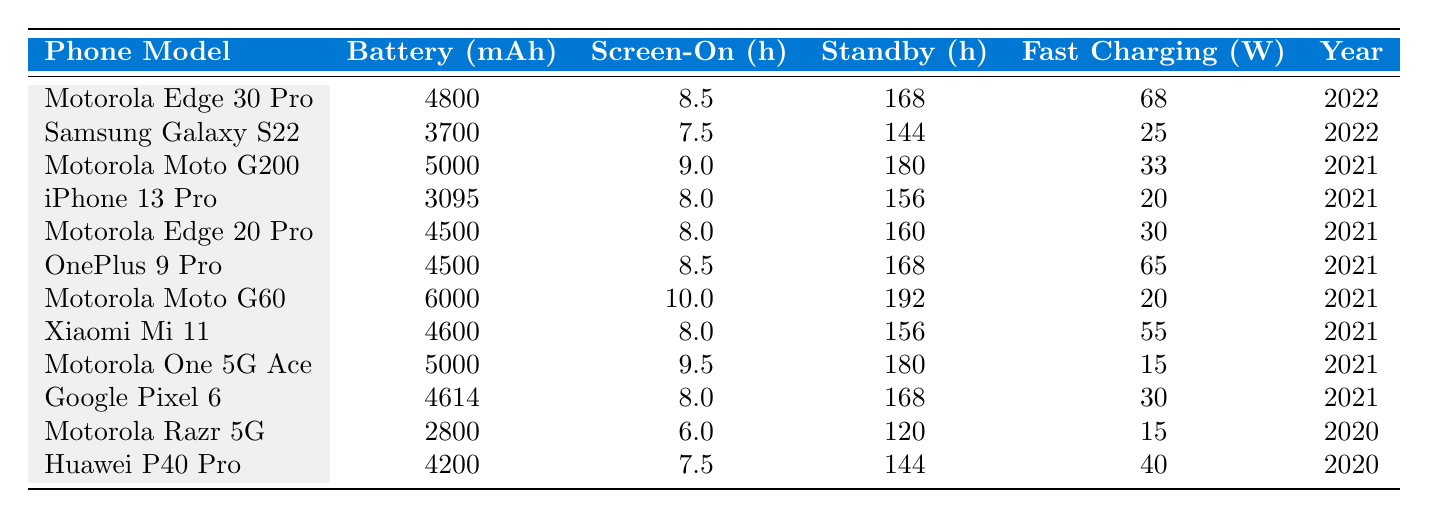What is the battery capacity of the Motorola Edge 30 Pro? The table shows the battery capacity (mAh) for each phone model. For the Motorola Edge 30 Pro, the battery capacity is listed as 4800 mAh.
Answer: 4800 mAh Which phone has the highest average screen-on time? By reviewing the average screen-on time values, the Motorola Moto G60 has the highest average at 10.0 hours.
Answer: 10.0 hours How does the battery capacity of the Samsung Galaxy S22 compare to the iPhone 13 Pro? The Samsung Galaxy S22 has a battery capacity of 3700 mAh, while the iPhone 13 Pro has a capacity of 3095 mAh. The Samsung Galaxy S22 has a higher capacity by 605 mAh.
Answer: 605 mAh Is the Motorola Moto G200's standby time greater than that of the Huawei P40 Pro? The table indicates that the Motorola Moto G200 has a standby time of 180 hours, which is greater than the Huawei P40 Pro's standby time of 144 hours.
Answer: Yes What is the average battery capacity of all Motorola phones listed in the table? Summing the battery capacities of all Motorola phones: (4800 + 5000 + 4500 + 6000 + 5000 + 2800) = 28600 mAh. Since there are 6 Motorola phones, the average is 28600 mAh / 6 = 4766.67 mAh.
Answer: 4766.67 mAh Which phone has the lowest fast charging capability, and what is its capacity? The table shows that the Motorola Razr 5G has the lowest fast charging capability at 15 W.
Answer: 15 W Are there any Motorola phones with an average screen-on time of over 9 hours? Looking at the table, two Motorola models, the Moto G200 and the Moto G60, have average screen-on times of 9.0 and 10.0 hours respectively, which are both over 9 hours.
Answer: Yes What is the difference in standby time between the Motorola Edge 20 Pro and the Samsung Galaxy S22? The Motorola Edge 20 Pro has a standby time of 160 hours, while the Samsung Galaxy S22 has 144 hours. The difference is 160 - 144 = 16 hours.
Answer: 16 hours Which phone had the best fast charging capability, and what was the wattage? The Motorola Edge 30 Pro has the best fast charging capability at 68 W according to the table.
Answer: 68 W What are the average screen-on times for competitors of Motorola smartphones? Competitors and their screen-on times are: Samsung Galaxy S22 (7.5), iPhone 13 Pro (8.0), OnePlus 9 Pro (8.5), Xiaomi Mi 11 (8.0), Google Pixel 6 (8.0), and Huawei P40 Pro (7.5). The average is (7.5 + 8.0 + 8.5 + 8.0 + 8.0 + 7.5) / 6 = 7.83 hours.
Answer: 7.83 hours 